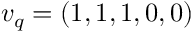Convert formula to latex. <formula><loc_0><loc_0><loc_500><loc_500>v _ { q } = ( 1 , 1 , 1 , 0 , 0 )</formula> 